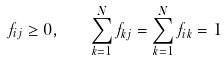<formula> <loc_0><loc_0><loc_500><loc_500>f _ { i j } \geq 0 , \quad \sum _ { k = 1 } ^ { N } f _ { k j } = \sum _ { k = 1 } ^ { N } f _ { i k } = 1</formula> 